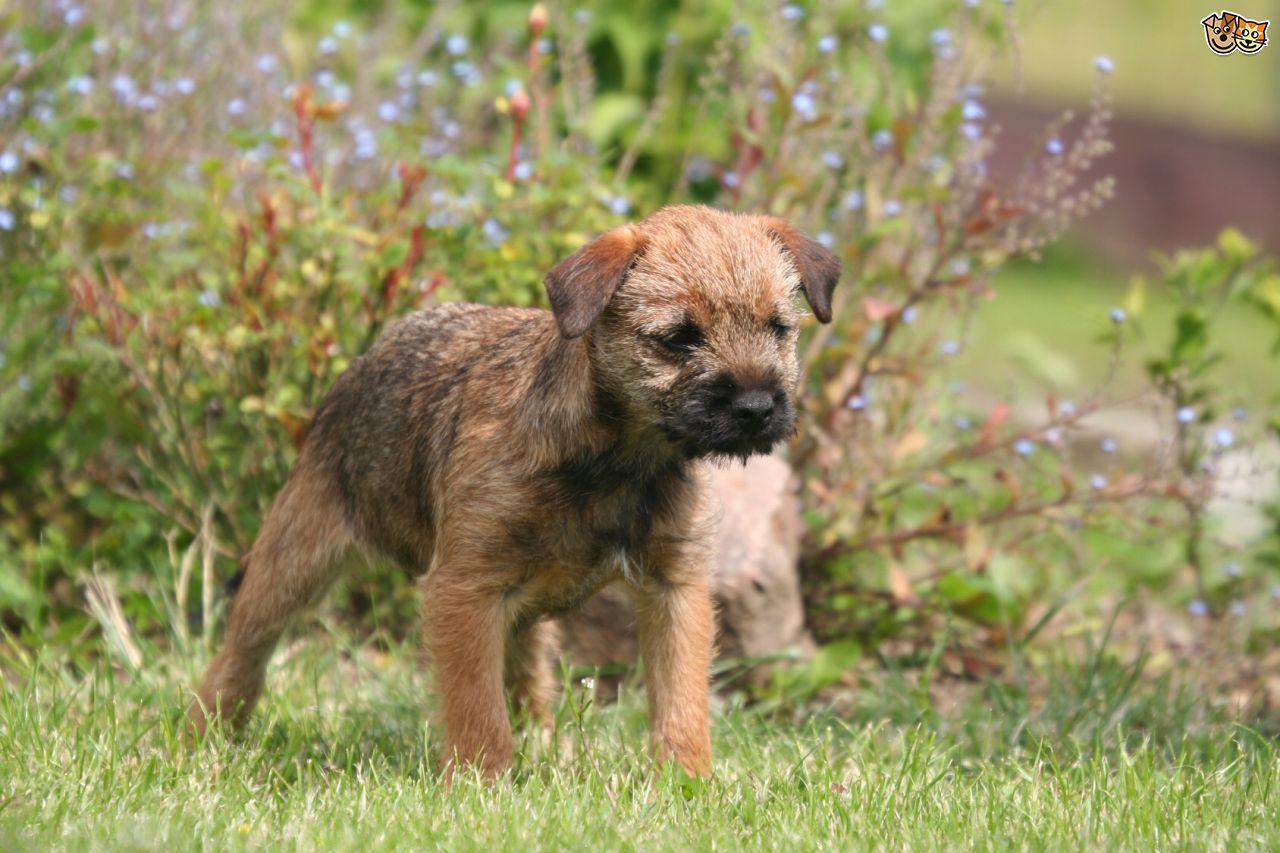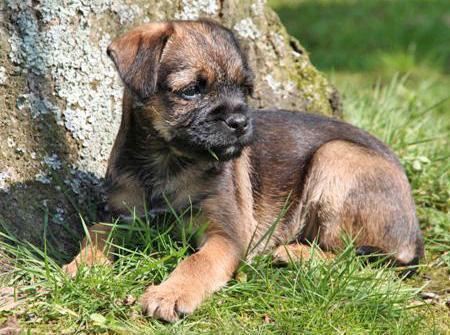The first image is the image on the left, the second image is the image on the right. For the images shown, is this caption "The dog in the image on the right is wearing a collar." true? Answer yes or no. No. The first image is the image on the left, the second image is the image on the right. Assess this claim about the two images: "A dog posed outdoors is wearing something that buckles and extends around its neck.". Correct or not? Answer yes or no. No. 